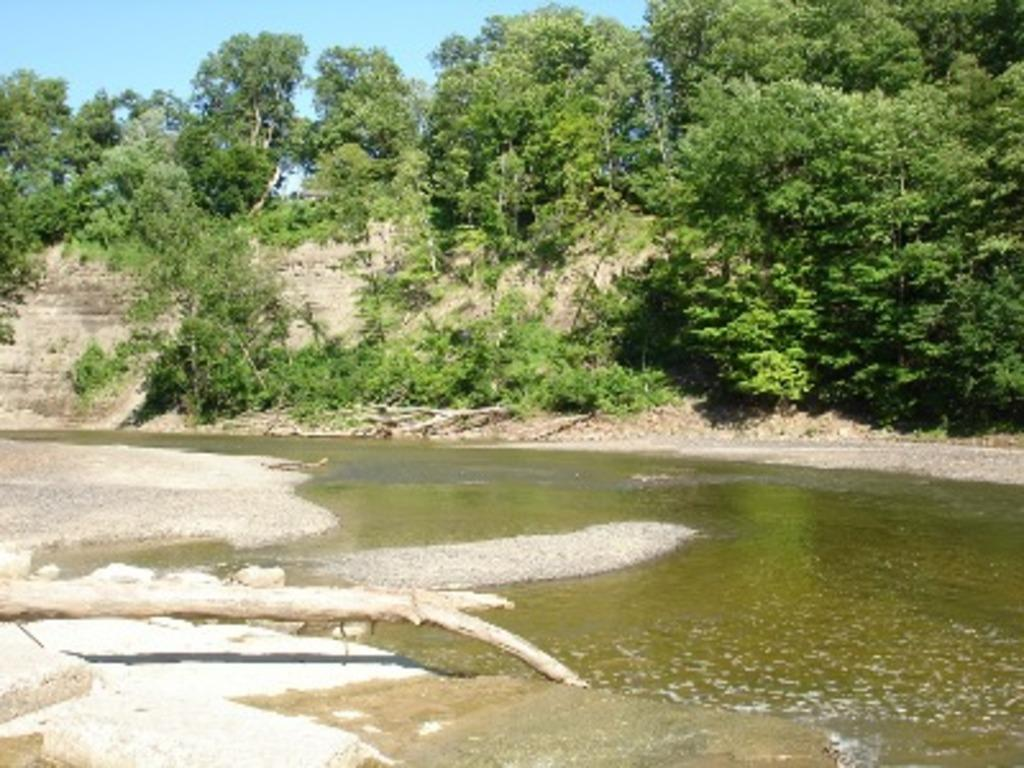What is the main feature in the foreground of the image? There is a water body in the foreground of the image. What object can be seen in the image besides the water body? There is a wood log in the image. What type of vegetation is visible in the background of the image? There are trees in the background of the image. How would you describe the sky in the image? The sky is clear in the image. What type of agreement is being discussed by the doctor in the sand in the image? There is no doctor or sand present in the image, and therefore no such discussion can be observed. 